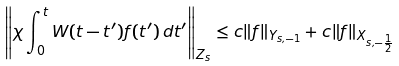Convert formula to latex. <formula><loc_0><loc_0><loc_500><loc_500>\left \| \chi \int _ { 0 } ^ { t } W ( t - t ^ { \prime } ) f ( t ^ { \prime } ) \, d t ^ { \prime } \right \| _ { Z _ { s } } \leq c \| f \| _ { Y _ { s , - 1 } } + c \| f \| _ { X _ { s , - \frac { 1 } { 2 } } }</formula> 